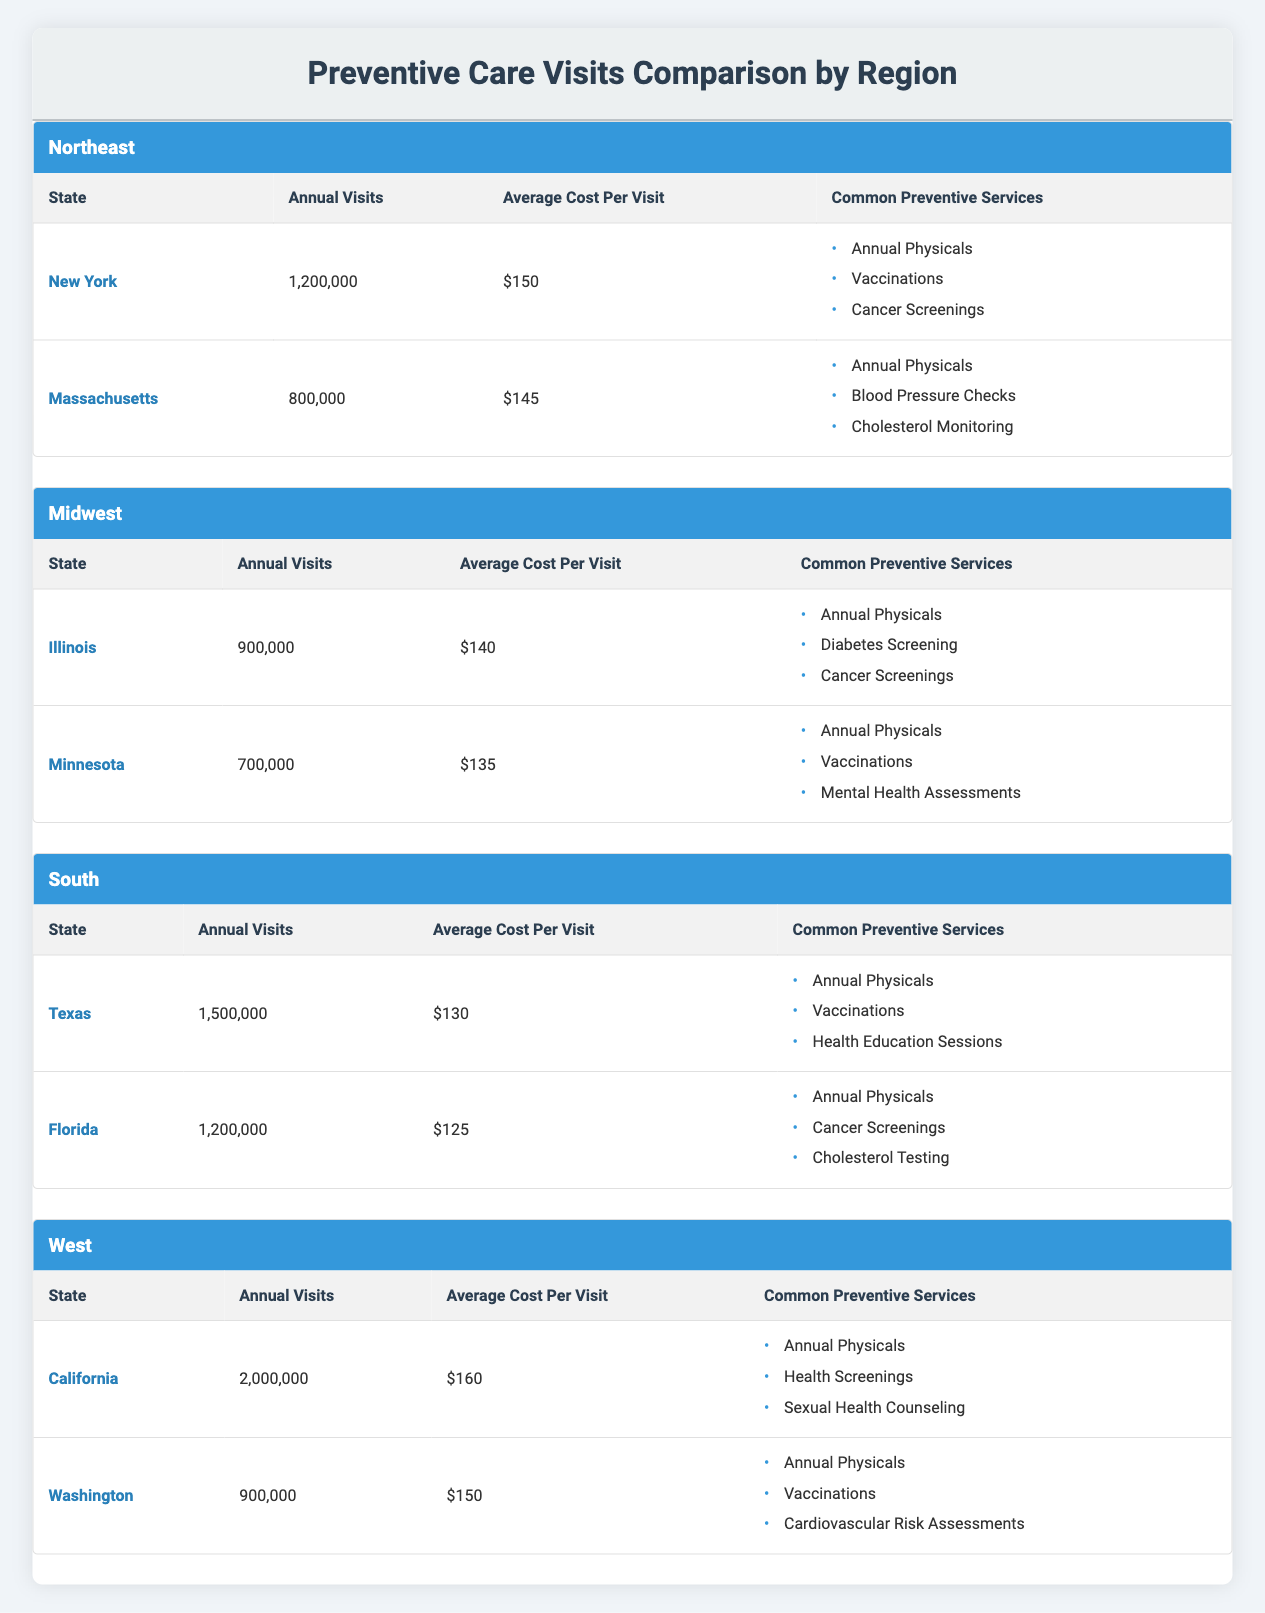What is the average cost per visit in the South region? In the South region, there are two states: Texas and Florida. The average cost per visit for Texas is 130, and for Florida, it is 125. To find the average for the South, sum these costs (130 + 125) and divide by the number of states (2): (130 + 125) / 2 = 255 / 2 = 127.5
Answer: 127.5 Which state has the highest number of annual visits? Looking at the table, California has the highest annual visits at 2,000,000. This value is greater than any other state listed in the table.
Answer: California Is the average cost per visit in the Northeast higher than in the Midwest? To determine this, compare the average costs: the Northeast has New York (150) and Massachusetts (145) with an average cost of (150 + 145) / 2 = 147.5. The Midwest has Illinois (140) and Minnesota (135) with an average of (140 + 135) / 2 = 137.5. Since 147.5 is greater than 137.5, the statement is true.
Answer: Yes How many total annual visits were made in the Northeast? Total annual visits for the Northeast are calculated by summing the annual visits of both states: New York (1,200,000) and Massachusetts (800,000), leading to a total of 1,200,000 + 800,000 = 2,000,000.
Answer: 2,000,000 What is the difference in annual visits between Texas and Minnesota? Texas has 1,500,000 annual visits and Minnesota has 700,000. The difference is calculated as follows: 1,500,000 - 700,000 = 800,000.
Answer: 800,000 